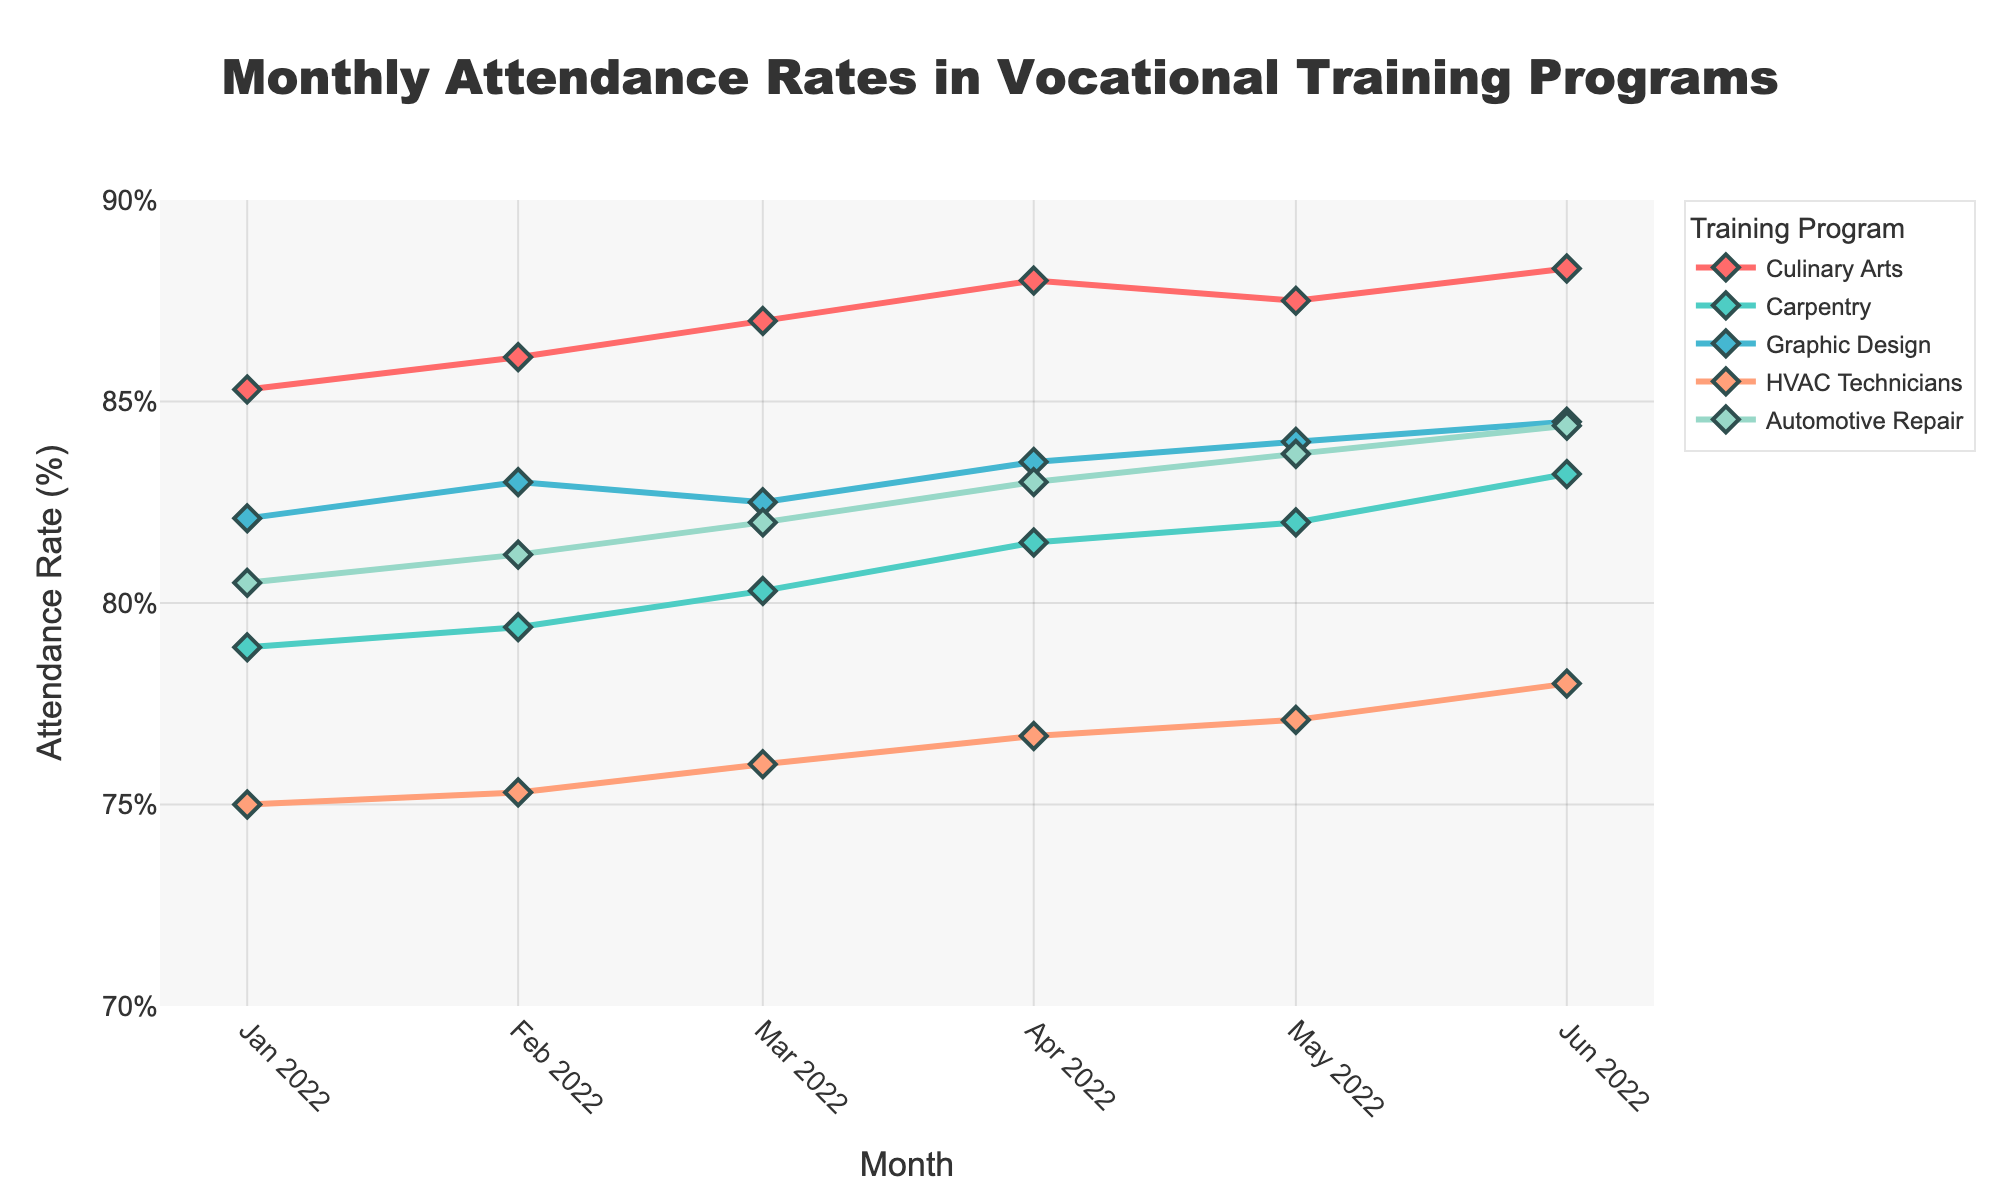What is the title of the figure? The title is typically placed at the top of the figure and describes the content of the data plot. In this case, the title mentions what the data is about.
Answer: Monthly Attendance Rates in Vocational Training Programs What is the range of attendance rates displayed on the y-axis? The y-axis in the figure represents the attendance rates and is usually labeled on the left side. By looking at the numerical range in this area, one can determine the minimum and maximum values.
Answer: 70% to 90% How did the attendance rate for Culinary Arts change from January to June 2022? Examine the line representing Culinary Arts on the graph. Track the data points from January to June and note the attendance rate values at each point to observe the change.
Answer: Increased from 85.3% to 88.3% Which training program had the lowest attendance rate in April 2022? Locate April 2022 on the x-axis. Then, examine the data points for each training program and find the one with the lowest y-axis value.
Answer: HVAC Technicians with 76.7% Between February and March 2022, which training program showed the largest increase in attendance rate? Identify the February and March data points for each program. Calculate the difference for each program by subtracting the February value from the March value. Compare the differences to find the largest increase.
Answer: Carpentry with an increase of 0.9% What's the average attendance rate for Graphic Design over the six months displayed? Sum the attendance rates for Graphic Design from January to June and divide by 6. The values are 82.1, 83.0, 82.5, 83.5, 84.0, and 84.5.
Answer: (82.1 + 83.0 + 82.5 + 83.5 + 84.0 + 84.5) / 6 = 83.27% Which training program had the most consistent attendance rate, with the smallest range, from January to June 2022? Calculate the range (highest value - lowest value) for each program over the six months. Compare these ranges to determine which is the smallest.
Answer: HVAC Technicians with a range of 3.0% (78.0% - 75.0%) Did any training program experience a decrease in attendance rate from May to June 2022? If so, which one? Check the data points for May and June for each program to see if any of them experienced a decrease (June value < May value).
Answer: No Which month saw the highest overall attendance rate for the Culinary Arts program? Examine the data points for Culinary Arts across all months and identify the month with the highest y-axis value.
Answer: June 2022 with 88.3% How did the attendance rate for Automotive Repair change from February to March 2022? Compare the attendance rates for Automotive Repair in February and March by checking the values at these points on the graph. Calculate the difference.
Answer: Increased from 81.2% to 82.0% 